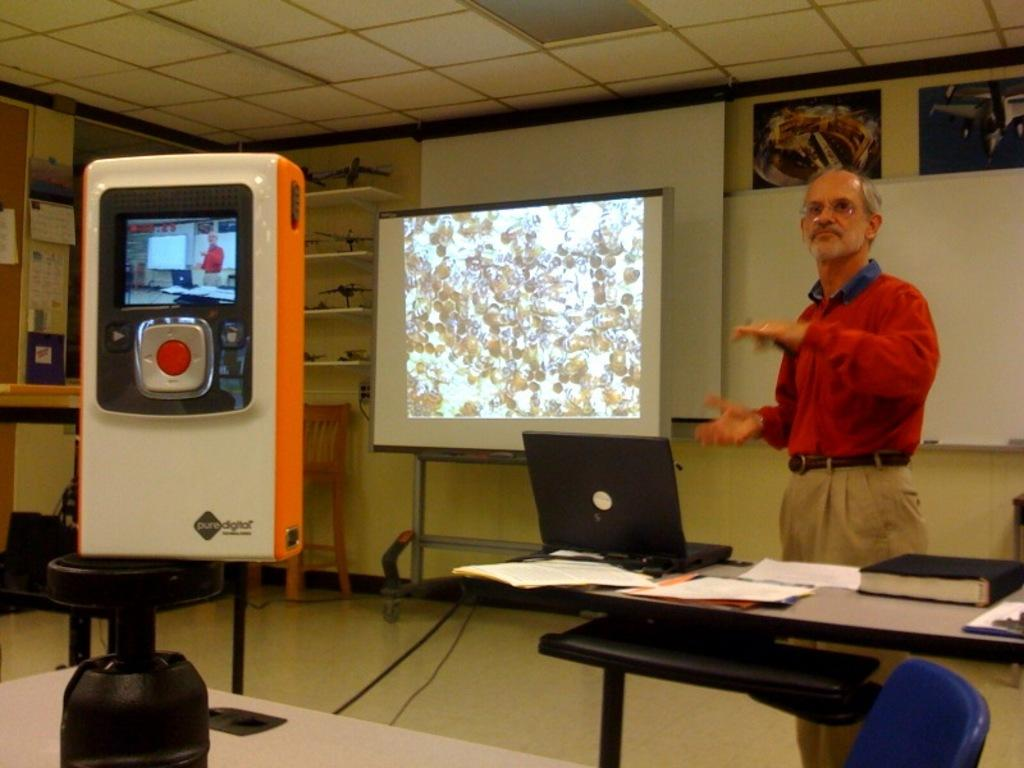What is the main object in the image? There is a projector screen in the image. What is the man in the image doing? A man is standing and speaking in the image. What else can be seen in the image besides the projector screen and the man? There are papers visible in the image, and there is a laptop on a table in the image. What type of rock is blocking the gate in the image? There is no rock or gate present in the image. 